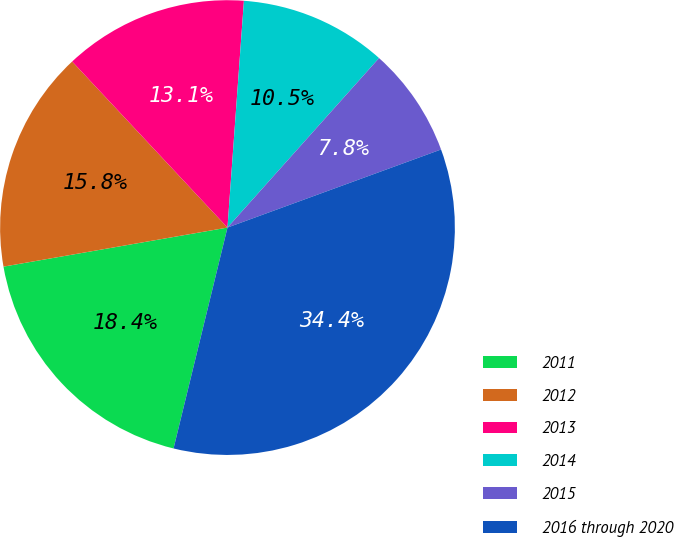Convert chart. <chart><loc_0><loc_0><loc_500><loc_500><pie_chart><fcel>2011<fcel>2012<fcel>2013<fcel>2014<fcel>2015<fcel>2016 through 2020<nl><fcel>18.44%<fcel>15.78%<fcel>13.12%<fcel>10.46%<fcel>7.81%<fcel>34.39%<nl></chart> 